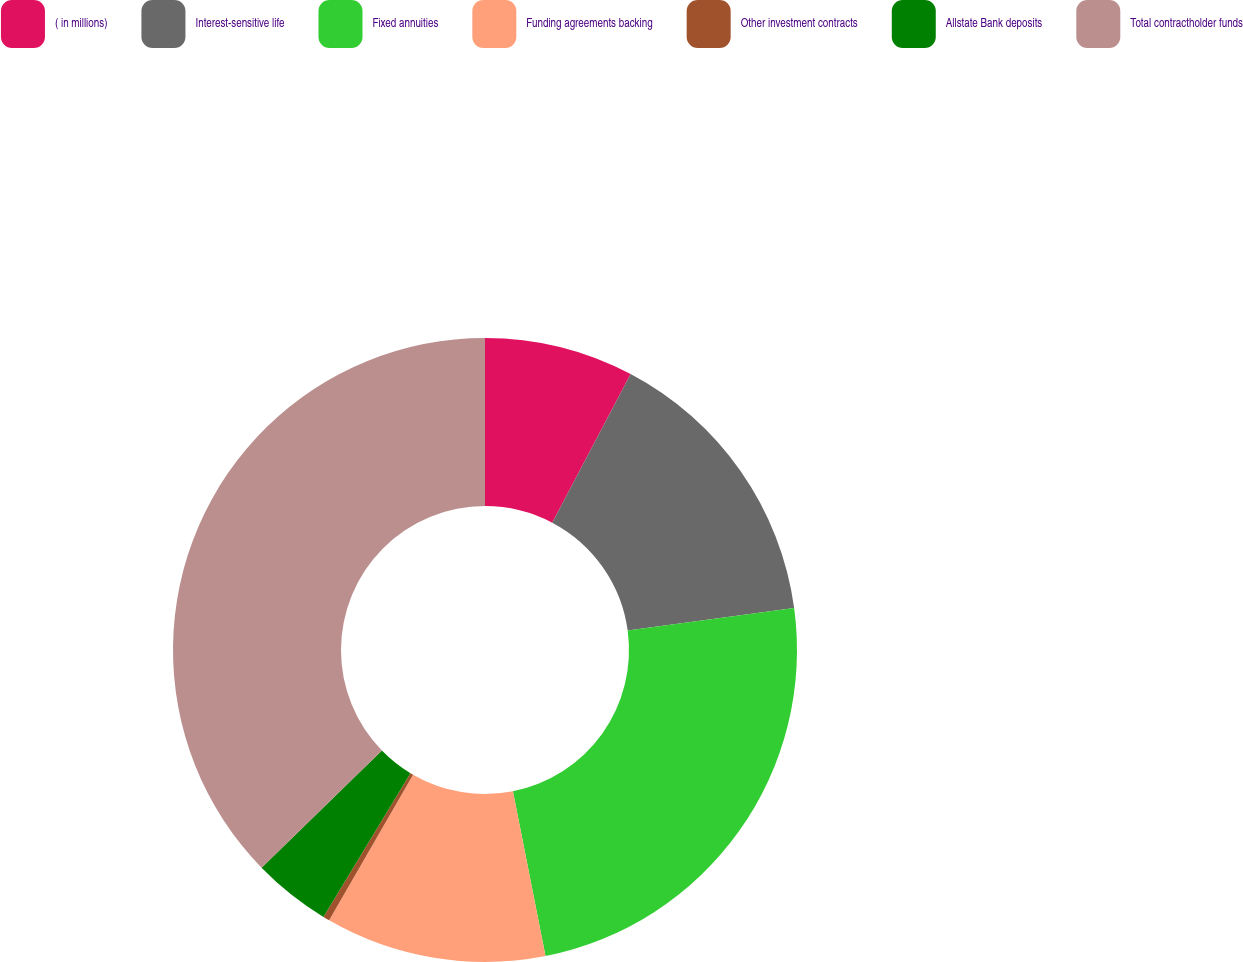Convert chart to OTSL. <chart><loc_0><loc_0><loc_500><loc_500><pie_chart><fcel>( in millions)<fcel>Interest-sensitive life<fcel>Fixed annuities<fcel>Funding agreements backing<fcel>Other investment contracts<fcel>Allstate Bank deposits<fcel>Total contractholder funds<nl><fcel>7.73%<fcel>15.12%<fcel>24.05%<fcel>11.43%<fcel>0.34%<fcel>4.04%<fcel>37.3%<nl></chart> 